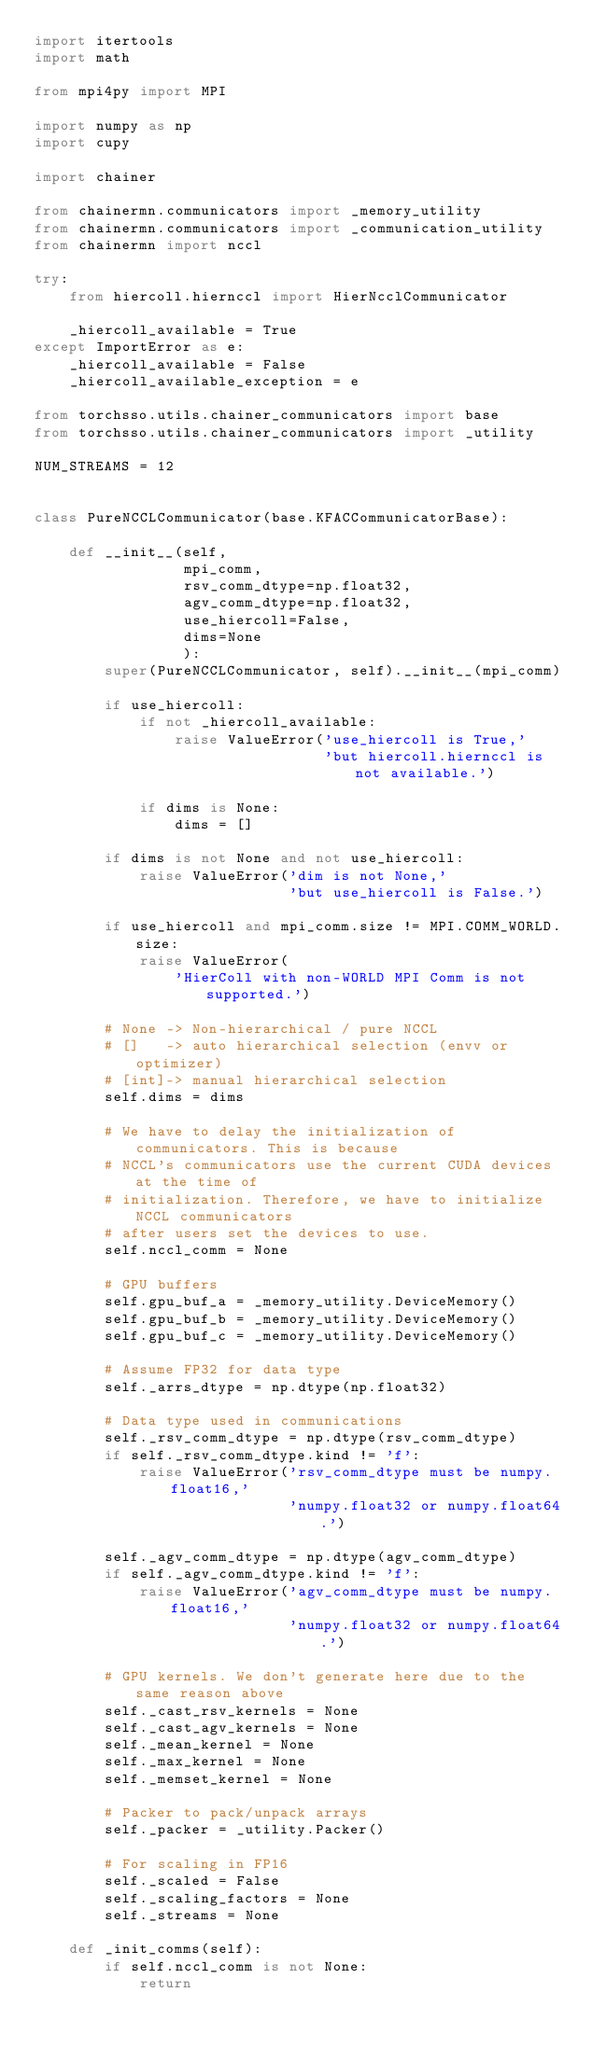Convert code to text. <code><loc_0><loc_0><loc_500><loc_500><_Python_>import itertools
import math

from mpi4py import MPI

import numpy as np
import cupy

import chainer

from chainermn.communicators import _memory_utility
from chainermn.communicators import _communication_utility
from chainermn import nccl

try:
    from hiercoll.hiernccl import HierNcclCommunicator

    _hiercoll_available = True
except ImportError as e:
    _hiercoll_available = False
    _hiercoll_available_exception = e

from torchsso.utils.chainer_communicators import base
from torchsso.utils.chainer_communicators import _utility

NUM_STREAMS = 12


class PureNCCLCommunicator(base.KFACCommunicatorBase):

    def __init__(self,
                 mpi_comm,
                 rsv_comm_dtype=np.float32,
                 agv_comm_dtype=np.float32,
                 use_hiercoll=False,
                 dims=None
                 ):
        super(PureNCCLCommunicator, self).__init__(mpi_comm)

        if use_hiercoll:
            if not _hiercoll_available:
                raise ValueError('use_hiercoll is True,'
                                 'but hiercoll.hiernccl is not available.')

            if dims is None:
                dims = []

        if dims is not None and not use_hiercoll:
            raise ValueError('dim is not None,'
                             'but use_hiercoll is False.')

        if use_hiercoll and mpi_comm.size != MPI.COMM_WORLD.size:
            raise ValueError(
                'HierColl with non-WORLD MPI Comm is not supported.')

        # None -> Non-hierarchical / pure NCCL
        # []   -> auto hierarchical selection (envv or optimizer)
        # [int]-> manual hierarchical selection
        self.dims = dims

        # We have to delay the initialization of communicators. This is because
        # NCCL's communicators use the current CUDA devices at the time of
        # initialization. Therefore, we have to initialize NCCL communicators
        # after users set the devices to use.
        self.nccl_comm = None

        # GPU buffers
        self.gpu_buf_a = _memory_utility.DeviceMemory()
        self.gpu_buf_b = _memory_utility.DeviceMemory()
        self.gpu_buf_c = _memory_utility.DeviceMemory()

        # Assume FP32 for data type
        self._arrs_dtype = np.dtype(np.float32)

        # Data type used in communications
        self._rsv_comm_dtype = np.dtype(rsv_comm_dtype)
        if self._rsv_comm_dtype.kind != 'f':
            raise ValueError('rsv_comm_dtype must be numpy.float16,'
                             'numpy.float32 or numpy.float64.')

        self._agv_comm_dtype = np.dtype(agv_comm_dtype)
        if self._agv_comm_dtype.kind != 'f':
            raise ValueError('agv_comm_dtype must be numpy.float16,'
                             'numpy.float32 or numpy.float64.')

        # GPU kernels. We don't generate here due to the same reason above
        self._cast_rsv_kernels = None
        self._cast_agv_kernels = None
        self._mean_kernel = None
        self._max_kernel = None
        self._memset_kernel = None

        # Packer to pack/unpack arrays
        self._packer = _utility.Packer()

        # For scaling in FP16
        self._scaled = False
        self._scaling_factors = None
        self._streams = None

    def _init_comms(self):
        if self.nccl_comm is not None:
            return
</code> 